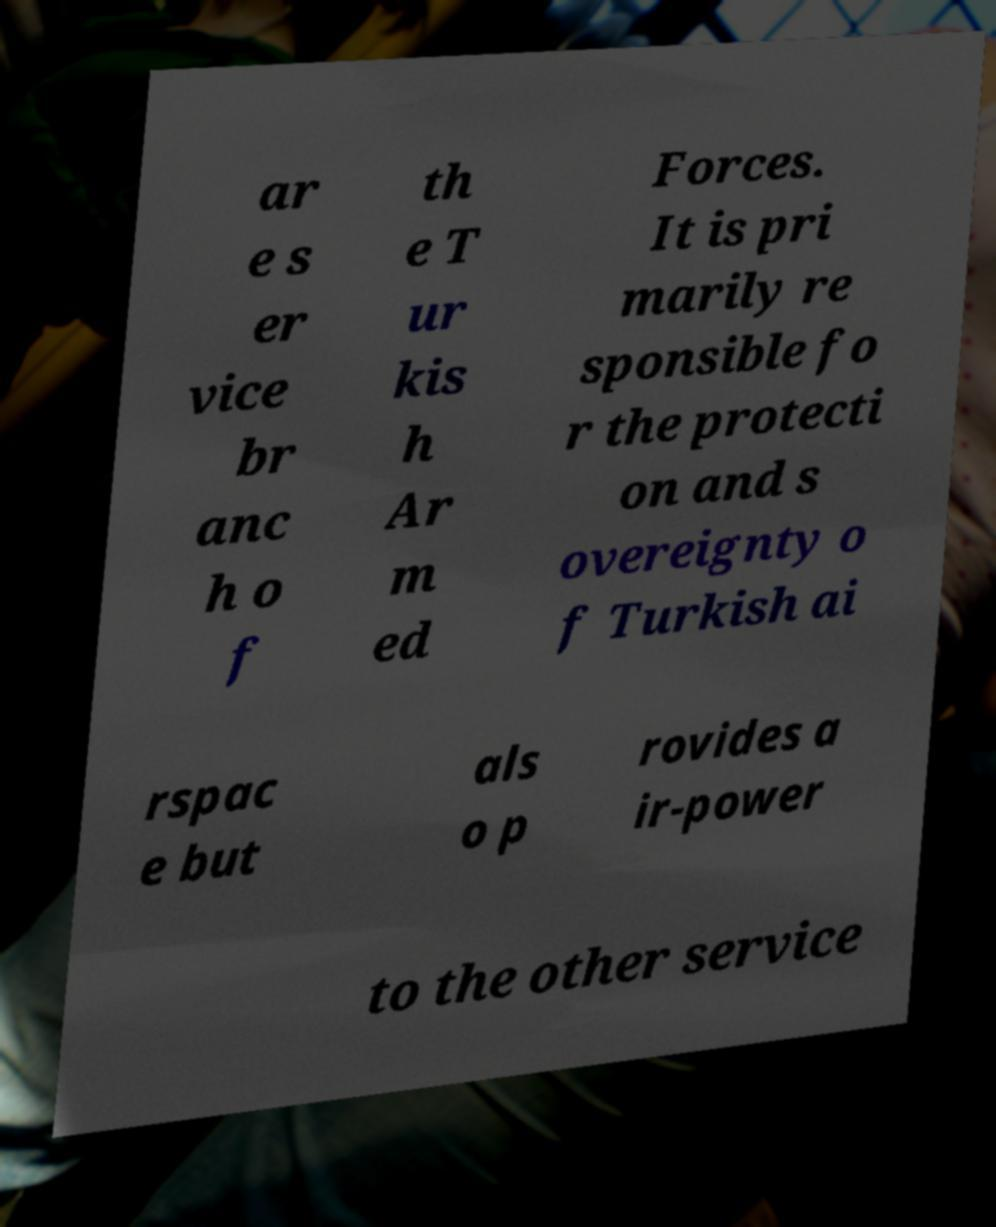Could you extract and type out the text from this image? ar e s er vice br anc h o f th e T ur kis h Ar m ed Forces. It is pri marily re sponsible fo r the protecti on and s overeignty o f Turkish ai rspac e but als o p rovides a ir-power to the other service 